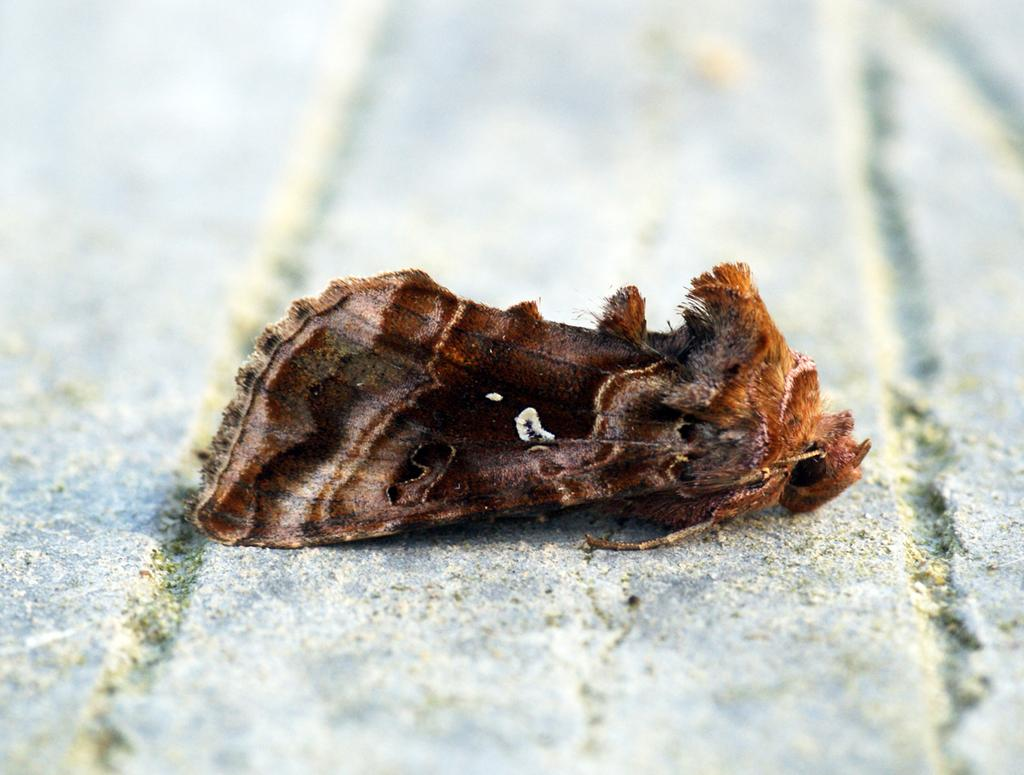What is the main subject of the image? There is a moth in the image. Where is the moth located in the image? The moth is on a surface. Can you describe the background of the image? The background of the image is blurry. What type of toys can be seen in the image? There are no toys present in the image; it features a moth on a surface with a blurry background. Is the moth feeling hot in the image? The image does not provide information about the moth's temperature, so it cannot be determined from the image. 